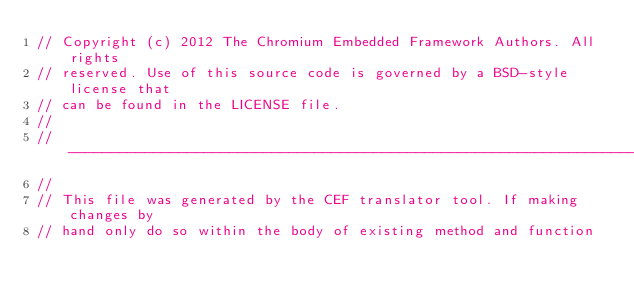Convert code to text. <code><loc_0><loc_0><loc_500><loc_500><_C_>// Copyright (c) 2012 The Chromium Embedded Framework Authors. All rights
// reserved. Use of this source code is governed by a BSD-style license that
// can be found in the LICENSE file.
//
// ---------------------------------------------------------------------------
//
// This file was generated by the CEF translator tool. If making changes by
// hand only do so within the body of existing method and function</code> 